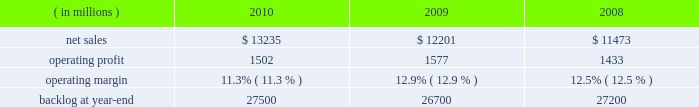The aeronautics segment generally includes fewer programs that have much larger sales and operating results than programs included in the other segments .
Due to the large number of comparatively smaller programs in the remaining segments , the discussion of the results of operations of those business segments focuses on lines of business within the segment rather than on specific programs .
The tables of financial information and related discussion of the results of operations of our business segments are consistent with the presentation of segment information in note 5 to the financial statements .
We have a number of programs that are classified by the u.s .
Government and cannot be specifically described .
The operating results of these classified programs are included in our consolidated and business segment results , and are subjected to the same oversight and internal controls as our other programs .
Aeronautics our aeronautics business segment is engaged in the research , design , development , manufacture , integration , sustainment , support , and upgrade of advanced military aircraft , including combat and air mobility aircraft , unmanned air vehicles , and related technologies .
Key combat aircraft programs include the f-35 lightning ii , f-16 fighting falcon , and f-22 raptor fighter aircraft .
Key air mobility programs include the c-130j super hercules and the c-5m super galaxy .
Aeronautics provides logistics support , sustainment , and upgrade modification services for its aircraft .
Aeronautics 2019 operating results included the following : ( in millions ) 2010 2009 2008 .
Net sales for aeronautics increased by 8% ( 8 % ) in 2010 compared to 2009 .
Sales increased in all three lines of business during the year .
The $ 800 million increase in air mobility primarily was attributable to higher volume on c-130 programs , including deliveries and support activities , as well as higher volume on the c-5 reliability enhancement and re-engining program ( rerp ) .
There were 25 c-130j deliveries in 2010 compared to 16 in 2009 .
The $ 179 million increase in combat aircraft principally was due to higher volume on f-35 production contracts , which partially was offset by lower volume on the f-35 sdd contract and a decline in volume on f-16 , f-22 and other combat aircraft programs .
There were 20 f-16 deliveries in 2010 compared to 31 in 2009 .
The $ 55 million increase in other aeronautics programs mainly was due to higher volume on p-3 and advanced development programs , which partially were offset by a decline in volume on sustainment activities .
Net sales for aeronautics increased by 6% ( 6 % ) in 2009 compared to 2008 .
During the year , sales increased in all three lines of business .
The increase of $ 296 million in air mobility 2019s sales primarily was attributable to higher volume on the c-130 programs , including deliveries and support activities .
There were 16 c-130j deliveries in 2009 and 12 in 2008 .
Combat aircraft sales increased $ 316 million principally due to higher volume on the f-35 program and increases in f-16 deliveries , which partially were offset by lower volume on f-22 and other combat aircraft programs .
There were 31 f-16 deliveries in 2009 compared to 28 in 2008 .
The $ 116 million increase in other aeronautics programs mainly was due to higher volume on p-3 programs and advanced development programs , which partially were offset by declines in sustainment activities .
Operating profit for the segment decreased by 5% ( 5 % ) in 2010 compared to 2009 .
A decline in operating profit in combat aircraft partially was offset by increases in other aeronautics programs and air mobility .
The $ 149 million decrease in combat aircraft 2019s operating profit primarily was due to lower volume and a decrease in the level of favorable performance adjustments on the f-22 program , the f-35 sdd contract and f-16 and other combat aircraft programs in 2010 .
These decreases more than offset increased operating profit resulting from higher volume and improved performance on f-35 production contracts in 2010 .
The $ 35 million increase in other aeronautics programs mainly was attributable to higher volume and improved performance on p-3 and advanced development programs as well as an increase in the level of favorable performance adjustments on sustainment activities in 2010 .
The $ 19 million increase in air mobility operating profit primarily was due to higher volume and improved performance in 2010 on c-130j support activities , which more than offset a decrease in operating profit due to a lower level of favorable performance adjustments on c-130j deliveries in 2010 .
The remaining change in operating profit is attributable to an increase in other income , net between the comparable periods .
Aeronautics 2019 2010 operating margins have decreased when compared to 2009 .
The operating margin decrease reflects the life cycles of our significant programs .
Specifically , aeronautics is performing more development and initial production work on the f-35 program and is performing less work on more mature programs such as the f-22 and f-16 .
Development and initial production contracts yield lower profits than mature full rate programs .
Accordingly , while net sales increased in 2010 relative to 2009 , operating profit decreased and consequently operating margins have declined. .
What are the total operating expenses for aeronautics in 2010? 
Computations: (13235 - 1502)
Answer: 11733.0. 